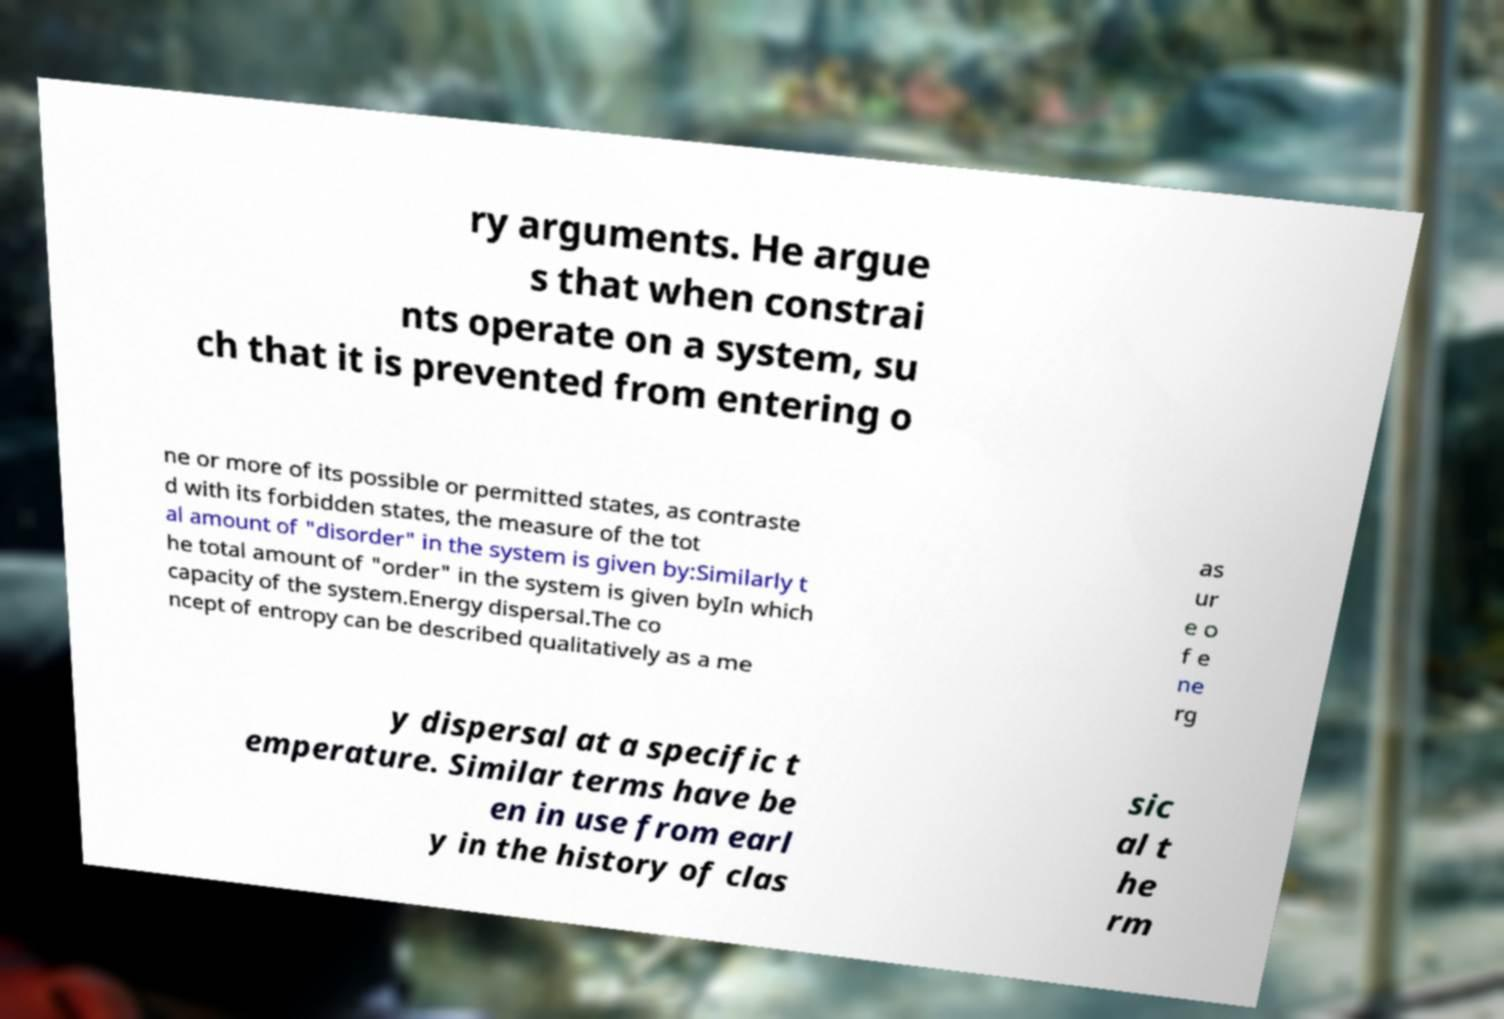For documentation purposes, I need the text within this image transcribed. Could you provide that? ry arguments. He argue s that when constrai nts operate on a system, su ch that it is prevented from entering o ne or more of its possible or permitted states, as contraste d with its forbidden states, the measure of the tot al amount of "disorder" in the system is given by:Similarly t he total amount of "order" in the system is given byIn which capacity of the system.Energy dispersal.The co ncept of entropy can be described qualitatively as a me as ur e o f e ne rg y dispersal at a specific t emperature. Similar terms have be en in use from earl y in the history of clas sic al t he rm 